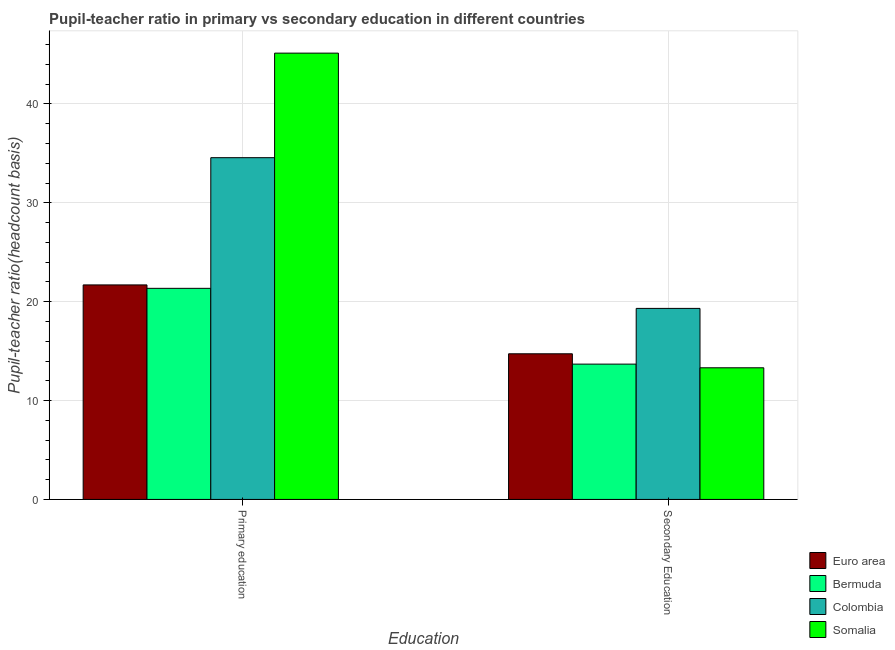Are the number of bars per tick equal to the number of legend labels?
Your answer should be compact. Yes. Are the number of bars on each tick of the X-axis equal?
Offer a very short reply. Yes. How many bars are there on the 2nd tick from the left?
Your answer should be very brief. 4. How many bars are there on the 1st tick from the right?
Provide a short and direct response. 4. What is the label of the 2nd group of bars from the left?
Provide a short and direct response. Secondary Education. What is the pupil teacher ratio on secondary education in Euro area?
Make the answer very short. 14.73. Across all countries, what is the maximum pupil teacher ratio on secondary education?
Your answer should be compact. 19.32. Across all countries, what is the minimum pupil-teacher ratio in primary education?
Make the answer very short. 21.35. In which country was the pupil teacher ratio on secondary education minimum?
Keep it short and to the point. Somalia. What is the total pupil teacher ratio on secondary education in the graph?
Your response must be concise. 61.05. What is the difference between the pupil teacher ratio on secondary education in Somalia and that in Euro area?
Your answer should be very brief. -1.42. What is the difference between the pupil-teacher ratio in primary education in Somalia and the pupil teacher ratio on secondary education in Euro area?
Your answer should be compact. 30.41. What is the average pupil teacher ratio on secondary education per country?
Provide a succinct answer. 15.26. What is the difference between the pupil teacher ratio on secondary education and pupil-teacher ratio in primary education in Bermuda?
Your answer should be very brief. -7.66. In how many countries, is the pupil teacher ratio on secondary education greater than 30 ?
Offer a very short reply. 0. What is the ratio of the pupil teacher ratio on secondary education in Bermuda to that in Euro area?
Ensure brevity in your answer.  0.93. Is the pupil-teacher ratio in primary education in Euro area less than that in Bermuda?
Provide a succinct answer. No. In how many countries, is the pupil teacher ratio on secondary education greater than the average pupil teacher ratio on secondary education taken over all countries?
Provide a short and direct response. 1. What does the 3rd bar from the right in Secondary Education represents?
Give a very brief answer. Bermuda. Are the values on the major ticks of Y-axis written in scientific E-notation?
Provide a short and direct response. No. Does the graph contain grids?
Provide a succinct answer. Yes. What is the title of the graph?
Your answer should be very brief. Pupil-teacher ratio in primary vs secondary education in different countries. Does "Guatemala" appear as one of the legend labels in the graph?
Offer a terse response. No. What is the label or title of the X-axis?
Provide a succinct answer. Education. What is the label or title of the Y-axis?
Your answer should be compact. Pupil-teacher ratio(headcount basis). What is the Pupil-teacher ratio(headcount basis) of Euro area in Primary education?
Offer a terse response. 21.7. What is the Pupil-teacher ratio(headcount basis) of Bermuda in Primary education?
Your response must be concise. 21.35. What is the Pupil-teacher ratio(headcount basis) of Colombia in Primary education?
Provide a succinct answer. 34.57. What is the Pupil-teacher ratio(headcount basis) in Somalia in Primary education?
Ensure brevity in your answer.  45.14. What is the Pupil-teacher ratio(headcount basis) in Euro area in Secondary Education?
Offer a very short reply. 14.73. What is the Pupil-teacher ratio(headcount basis) of Bermuda in Secondary Education?
Keep it short and to the point. 13.69. What is the Pupil-teacher ratio(headcount basis) of Colombia in Secondary Education?
Offer a very short reply. 19.32. What is the Pupil-teacher ratio(headcount basis) of Somalia in Secondary Education?
Provide a short and direct response. 13.31. Across all Education, what is the maximum Pupil-teacher ratio(headcount basis) in Euro area?
Ensure brevity in your answer.  21.7. Across all Education, what is the maximum Pupil-teacher ratio(headcount basis) in Bermuda?
Make the answer very short. 21.35. Across all Education, what is the maximum Pupil-teacher ratio(headcount basis) in Colombia?
Ensure brevity in your answer.  34.57. Across all Education, what is the maximum Pupil-teacher ratio(headcount basis) of Somalia?
Provide a succinct answer. 45.14. Across all Education, what is the minimum Pupil-teacher ratio(headcount basis) of Euro area?
Your answer should be compact. 14.73. Across all Education, what is the minimum Pupil-teacher ratio(headcount basis) in Bermuda?
Give a very brief answer. 13.69. Across all Education, what is the minimum Pupil-teacher ratio(headcount basis) in Colombia?
Offer a terse response. 19.32. Across all Education, what is the minimum Pupil-teacher ratio(headcount basis) of Somalia?
Your answer should be compact. 13.31. What is the total Pupil-teacher ratio(headcount basis) of Euro area in the graph?
Provide a short and direct response. 36.43. What is the total Pupil-teacher ratio(headcount basis) in Bermuda in the graph?
Provide a succinct answer. 35.04. What is the total Pupil-teacher ratio(headcount basis) of Colombia in the graph?
Provide a succinct answer. 53.89. What is the total Pupil-teacher ratio(headcount basis) in Somalia in the graph?
Your answer should be compact. 58.45. What is the difference between the Pupil-teacher ratio(headcount basis) in Euro area in Primary education and that in Secondary Education?
Your response must be concise. 6.97. What is the difference between the Pupil-teacher ratio(headcount basis) in Bermuda in Primary education and that in Secondary Education?
Provide a short and direct response. 7.66. What is the difference between the Pupil-teacher ratio(headcount basis) of Colombia in Primary education and that in Secondary Education?
Your response must be concise. 15.25. What is the difference between the Pupil-teacher ratio(headcount basis) of Somalia in Primary education and that in Secondary Education?
Provide a short and direct response. 31.83. What is the difference between the Pupil-teacher ratio(headcount basis) in Euro area in Primary education and the Pupil-teacher ratio(headcount basis) in Bermuda in Secondary Education?
Ensure brevity in your answer.  8.01. What is the difference between the Pupil-teacher ratio(headcount basis) in Euro area in Primary education and the Pupil-teacher ratio(headcount basis) in Colombia in Secondary Education?
Provide a short and direct response. 2.38. What is the difference between the Pupil-teacher ratio(headcount basis) in Euro area in Primary education and the Pupil-teacher ratio(headcount basis) in Somalia in Secondary Education?
Make the answer very short. 8.38. What is the difference between the Pupil-teacher ratio(headcount basis) in Bermuda in Primary education and the Pupil-teacher ratio(headcount basis) in Colombia in Secondary Education?
Make the answer very short. 2.03. What is the difference between the Pupil-teacher ratio(headcount basis) in Bermuda in Primary education and the Pupil-teacher ratio(headcount basis) in Somalia in Secondary Education?
Your answer should be very brief. 8.04. What is the difference between the Pupil-teacher ratio(headcount basis) in Colombia in Primary education and the Pupil-teacher ratio(headcount basis) in Somalia in Secondary Education?
Your answer should be compact. 21.25. What is the average Pupil-teacher ratio(headcount basis) of Euro area per Education?
Ensure brevity in your answer.  18.21. What is the average Pupil-teacher ratio(headcount basis) in Bermuda per Education?
Make the answer very short. 17.52. What is the average Pupil-teacher ratio(headcount basis) of Colombia per Education?
Your answer should be compact. 26.94. What is the average Pupil-teacher ratio(headcount basis) of Somalia per Education?
Your answer should be very brief. 29.23. What is the difference between the Pupil-teacher ratio(headcount basis) of Euro area and Pupil-teacher ratio(headcount basis) of Bermuda in Primary education?
Your answer should be compact. 0.35. What is the difference between the Pupil-teacher ratio(headcount basis) of Euro area and Pupil-teacher ratio(headcount basis) of Colombia in Primary education?
Your answer should be very brief. -12.87. What is the difference between the Pupil-teacher ratio(headcount basis) of Euro area and Pupil-teacher ratio(headcount basis) of Somalia in Primary education?
Give a very brief answer. -23.44. What is the difference between the Pupil-teacher ratio(headcount basis) of Bermuda and Pupil-teacher ratio(headcount basis) of Colombia in Primary education?
Your answer should be compact. -13.22. What is the difference between the Pupil-teacher ratio(headcount basis) of Bermuda and Pupil-teacher ratio(headcount basis) of Somalia in Primary education?
Your answer should be very brief. -23.79. What is the difference between the Pupil-teacher ratio(headcount basis) of Colombia and Pupil-teacher ratio(headcount basis) of Somalia in Primary education?
Provide a short and direct response. -10.57. What is the difference between the Pupil-teacher ratio(headcount basis) of Euro area and Pupil-teacher ratio(headcount basis) of Bermuda in Secondary Education?
Offer a terse response. 1.05. What is the difference between the Pupil-teacher ratio(headcount basis) in Euro area and Pupil-teacher ratio(headcount basis) in Colombia in Secondary Education?
Your answer should be very brief. -4.59. What is the difference between the Pupil-teacher ratio(headcount basis) of Euro area and Pupil-teacher ratio(headcount basis) of Somalia in Secondary Education?
Your answer should be very brief. 1.42. What is the difference between the Pupil-teacher ratio(headcount basis) in Bermuda and Pupil-teacher ratio(headcount basis) in Colombia in Secondary Education?
Keep it short and to the point. -5.64. What is the difference between the Pupil-teacher ratio(headcount basis) in Bermuda and Pupil-teacher ratio(headcount basis) in Somalia in Secondary Education?
Keep it short and to the point. 0.37. What is the difference between the Pupil-teacher ratio(headcount basis) of Colombia and Pupil-teacher ratio(headcount basis) of Somalia in Secondary Education?
Make the answer very short. 6.01. What is the ratio of the Pupil-teacher ratio(headcount basis) in Euro area in Primary education to that in Secondary Education?
Provide a succinct answer. 1.47. What is the ratio of the Pupil-teacher ratio(headcount basis) of Bermuda in Primary education to that in Secondary Education?
Provide a short and direct response. 1.56. What is the ratio of the Pupil-teacher ratio(headcount basis) in Colombia in Primary education to that in Secondary Education?
Your answer should be very brief. 1.79. What is the ratio of the Pupil-teacher ratio(headcount basis) in Somalia in Primary education to that in Secondary Education?
Give a very brief answer. 3.39. What is the difference between the highest and the second highest Pupil-teacher ratio(headcount basis) in Euro area?
Provide a short and direct response. 6.97. What is the difference between the highest and the second highest Pupil-teacher ratio(headcount basis) in Bermuda?
Keep it short and to the point. 7.66. What is the difference between the highest and the second highest Pupil-teacher ratio(headcount basis) of Colombia?
Offer a terse response. 15.25. What is the difference between the highest and the second highest Pupil-teacher ratio(headcount basis) of Somalia?
Keep it short and to the point. 31.83. What is the difference between the highest and the lowest Pupil-teacher ratio(headcount basis) of Euro area?
Offer a very short reply. 6.97. What is the difference between the highest and the lowest Pupil-teacher ratio(headcount basis) in Bermuda?
Your answer should be very brief. 7.66. What is the difference between the highest and the lowest Pupil-teacher ratio(headcount basis) in Colombia?
Provide a succinct answer. 15.25. What is the difference between the highest and the lowest Pupil-teacher ratio(headcount basis) in Somalia?
Your answer should be compact. 31.83. 